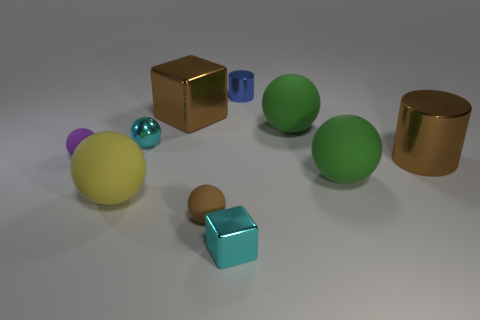There is a cyan object that is behind the small cyan shiny thing in front of the yellow sphere; what is its size?
Your answer should be very brief. Small. Is the small metallic cube the same color as the metal sphere?
Keep it short and to the point. Yes. The purple matte object has what size?
Give a very brief answer. Small. What material is the big thing that is the same color as the big cylinder?
Provide a short and direct response. Metal. Is there any other thing that has the same shape as the large yellow matte object?
Your answer should be compact. Yes. What material is the cyan thing that is in front of the brown ball?
Your response must be concise. Metal. Are the purple object left of the tiny brown thing and the tiny brown object made of the same material?
Keep it short and to the point. Yes. What number of objects are blue things or large matte objects behind the yellow matte object?
Your response must be concise. 3. The other metal object that is the same shape as the tiny blue metal thing is what size?
Your answer should be very brief. Large. Are there any other things that have the same size as the yellow object?
Ensure brevity in your answer.  Yes. 